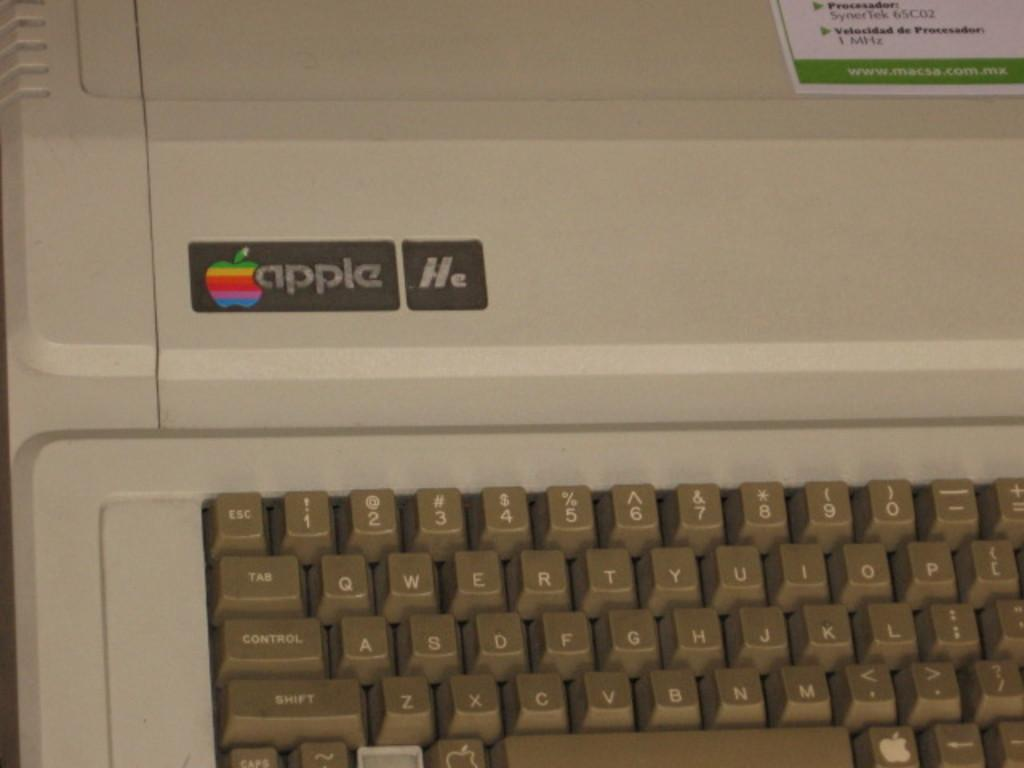<image>
Share a concise interpretation of the image provided. the left half of an old Apple computer keyboard 